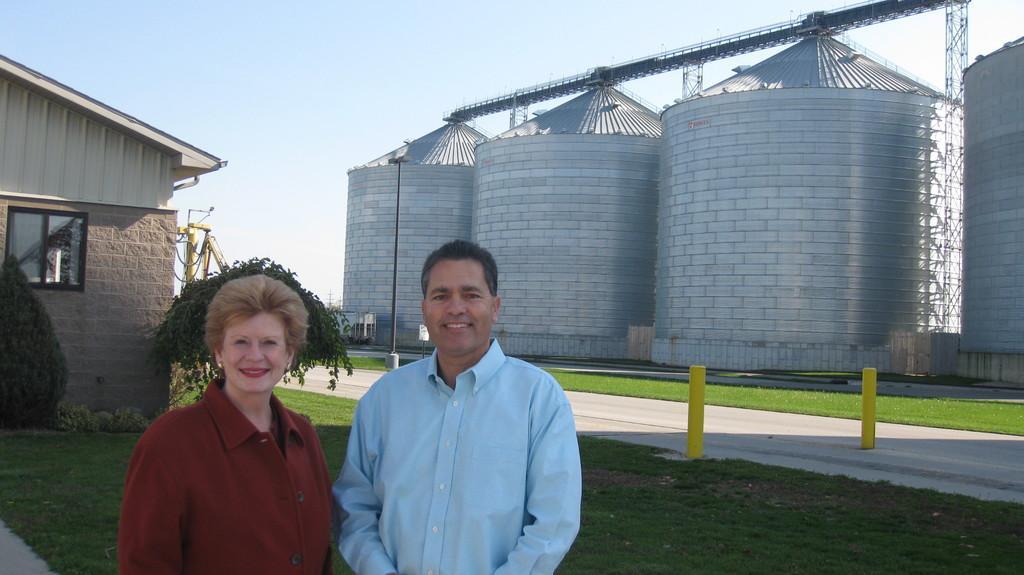Can you describe this image briefly? In this image we can see one house, four Silos, some objects attached to the silos, some iron rods, two yellow rods on the road, one object with pole, one board with pole, one object near the silo, it looks like a wall with two doors near the silos, two objects looks like poles in the background, one yellow color object looks like a crane near the house, two trees, some plants and grass on the ground. One woman and one man with smiling faces standing on the ground. In the background there is the sky. 